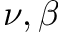<formula> <loc_0><loc_0><loc_500><loc_500>\nu , \beta</formula> 